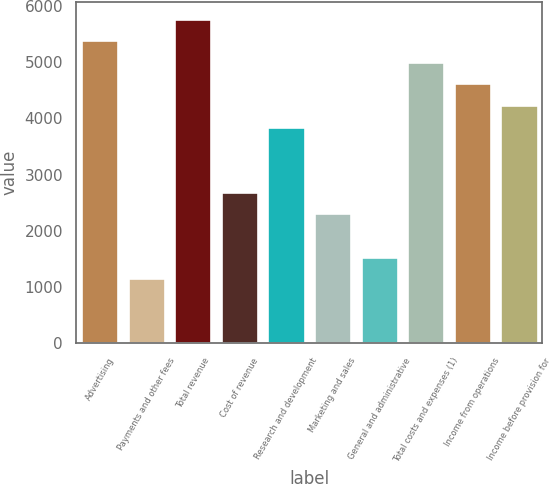Convert chart. <chart><loc_0><loc_0><loc_500><loc_500><bar_chart><fcel>Advertising<fcel>Payments and other fees<fcel>Total revenue<fcel>Cost of revenue<fcel>Research and development<fcel>Marketing and sales<fcel>General and administrative<fcel>Total costs and expenses (1)<fcel>Income from operations<fcel>Income before provision for<nl><fcel>5391.3<fcel>1155.47<fcel>5776.38<fcel>2695.77<fcel>3851.01<fcel>2310.69<fcel>1540.55<fcel>5006.23<fcel>4621.16<fcel>4236.09<nl></chart> 